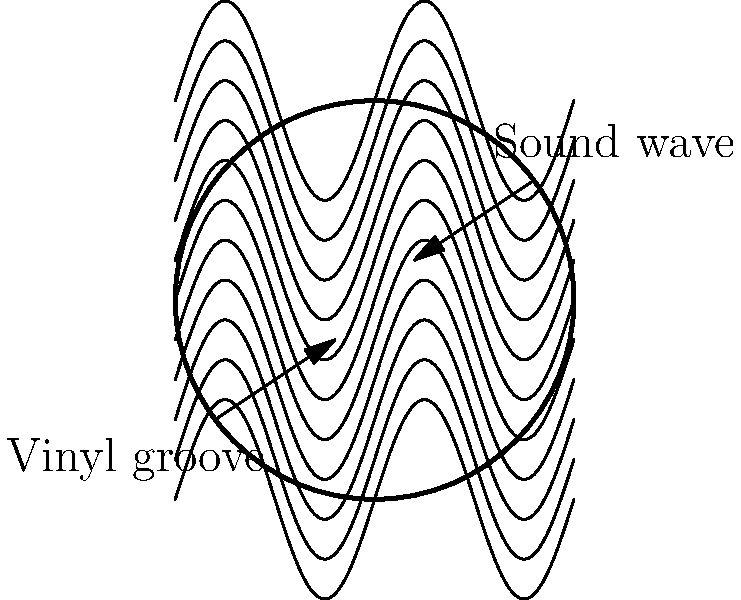As a radio DJ with extensive knowledge of classic rock, you're explaining the physics behind vinyl records to your listeners. How does the amplitude of the sound wave correspond to the physical groove on a vinyl record, and what effect does this have on the playback volume? To understand the relationship between sound waves and vinyl record grooves, let's break it down step-by-step:

1. Sound waves are represented by oscillations in air pressure. These oscillations can be graphed as a wave function, where:
   - The horizontal axis represents time
   - The vertical axis represents the amplitude (intensity) of the sound

2. On a vinyl record, these sound waves are physically encoded into the grooves:
   - The groove's lateral (side-to-side) deviation from a perfect spiral corresponds to the wave's shape
   - The magnitude of this deviation corresponds to the wave's amplitude

3. Amplitude and volume relationship:
   - Higher amplitude sound waves create wider deviations in the groove
   - Lower amplitude sound waves create narrower deviations

4. During playback:
   - The stylus (needle) follows these groove deviations
   - Wider deviations cause larger movements of the stylus
   - These larger movements are translated into higher electrical signals by the cartridge

5. Effect on volume:
   - Larger electrical signals from the cartridge result in louder playback volume
   - Smaller electrical signals result in quieter playback volume

Therefore, the amplitude of the sound wave directly corresponds to the width of the groove's deviation from a perfect spiral. This, in turn, affects the playback volume: higher amplitude waves (wider groove deviations) produce louder sounds, while lower amplitude waves (narrower groove deviations) produce quieter sounds.
Answer: Higher amplitude waves create wider groove deviations, resulting in louder playback volume. 